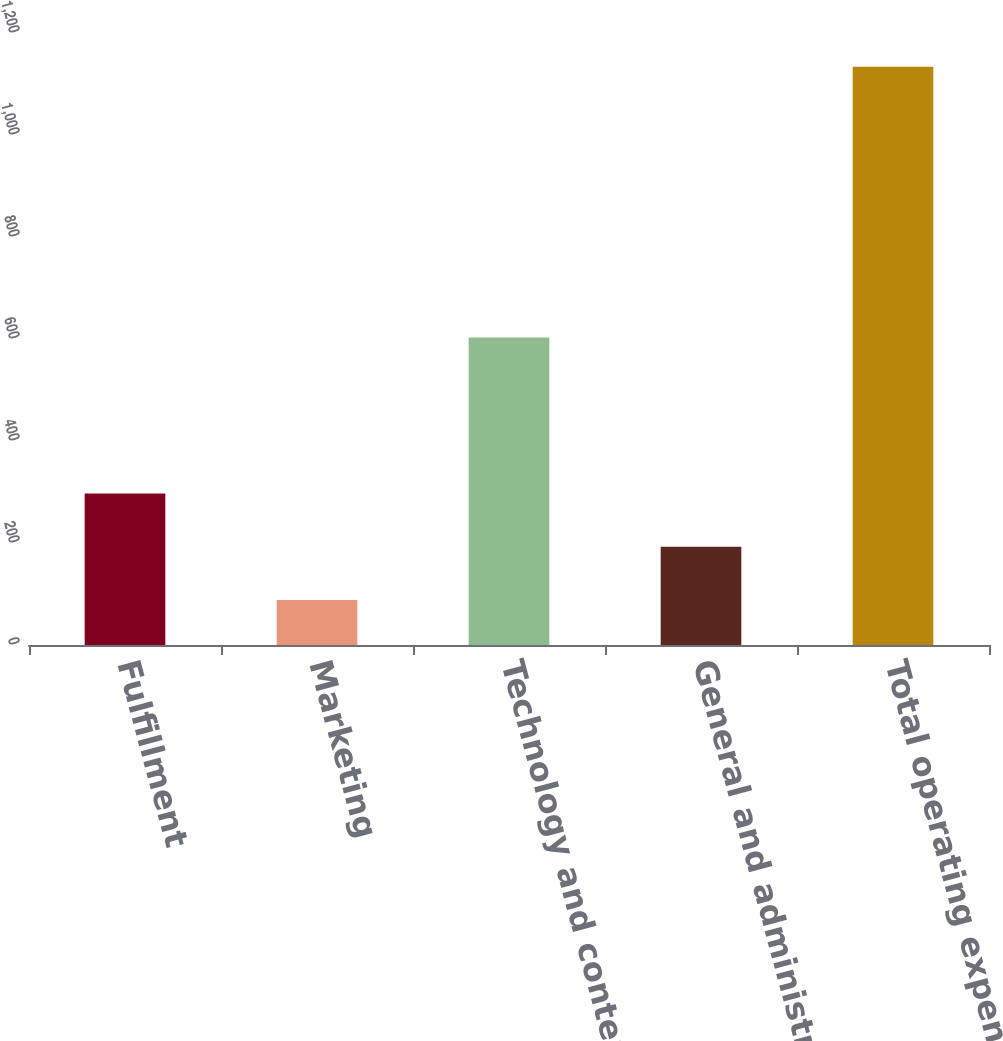Convert chart to OTSL. <chart><loc_0><loc_0><loc_500><loc_500><bar_chart><fcel>Fulfillment<fcel>Marketing<fcel>Technology and content<fcel>General and administrative<fcel>Total operating expenses<nl><fcel>297.2<fcel>88<fcel>603<fcel>192.6<fcel>1134<nl></chart> 